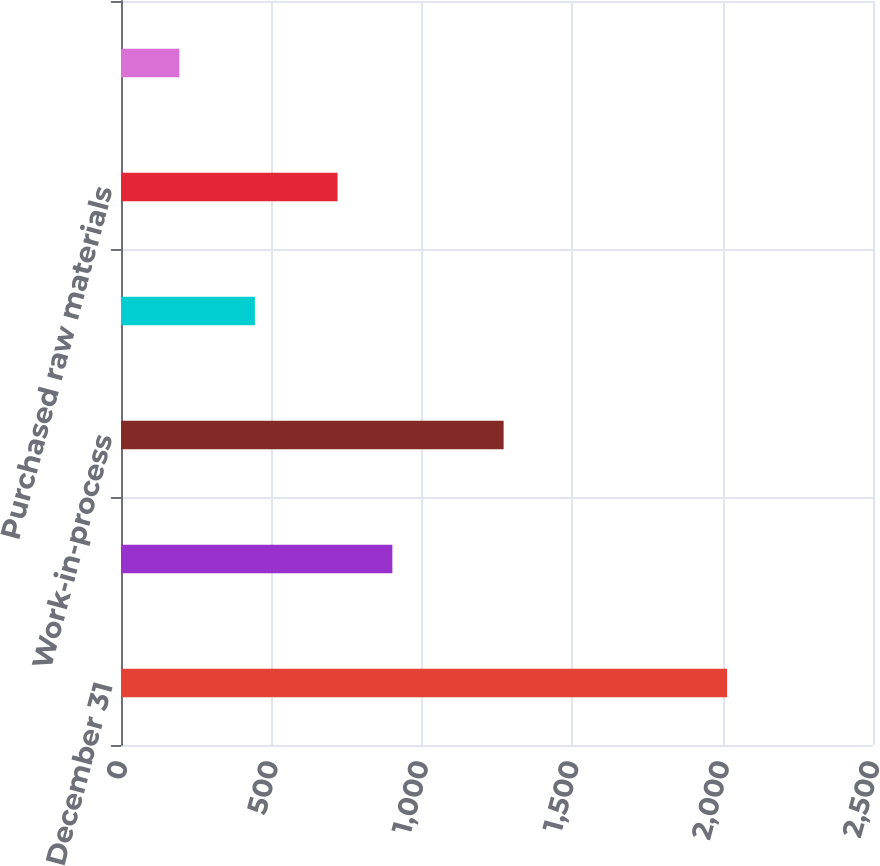<chart> <loc_0><loc_0><loc_500><loc_500><bar_chart><fcel>December 31<fcel>Finished goods<fcel>Work-in-process<fcel>Bauxite and alumina<fcel>Purchased raw materials<fcel>Operating supplies<nl><fcel>2015<fcel>902.1<fcel>1272<fcel>445<fcel>720<fcel>194<nl></chart> 